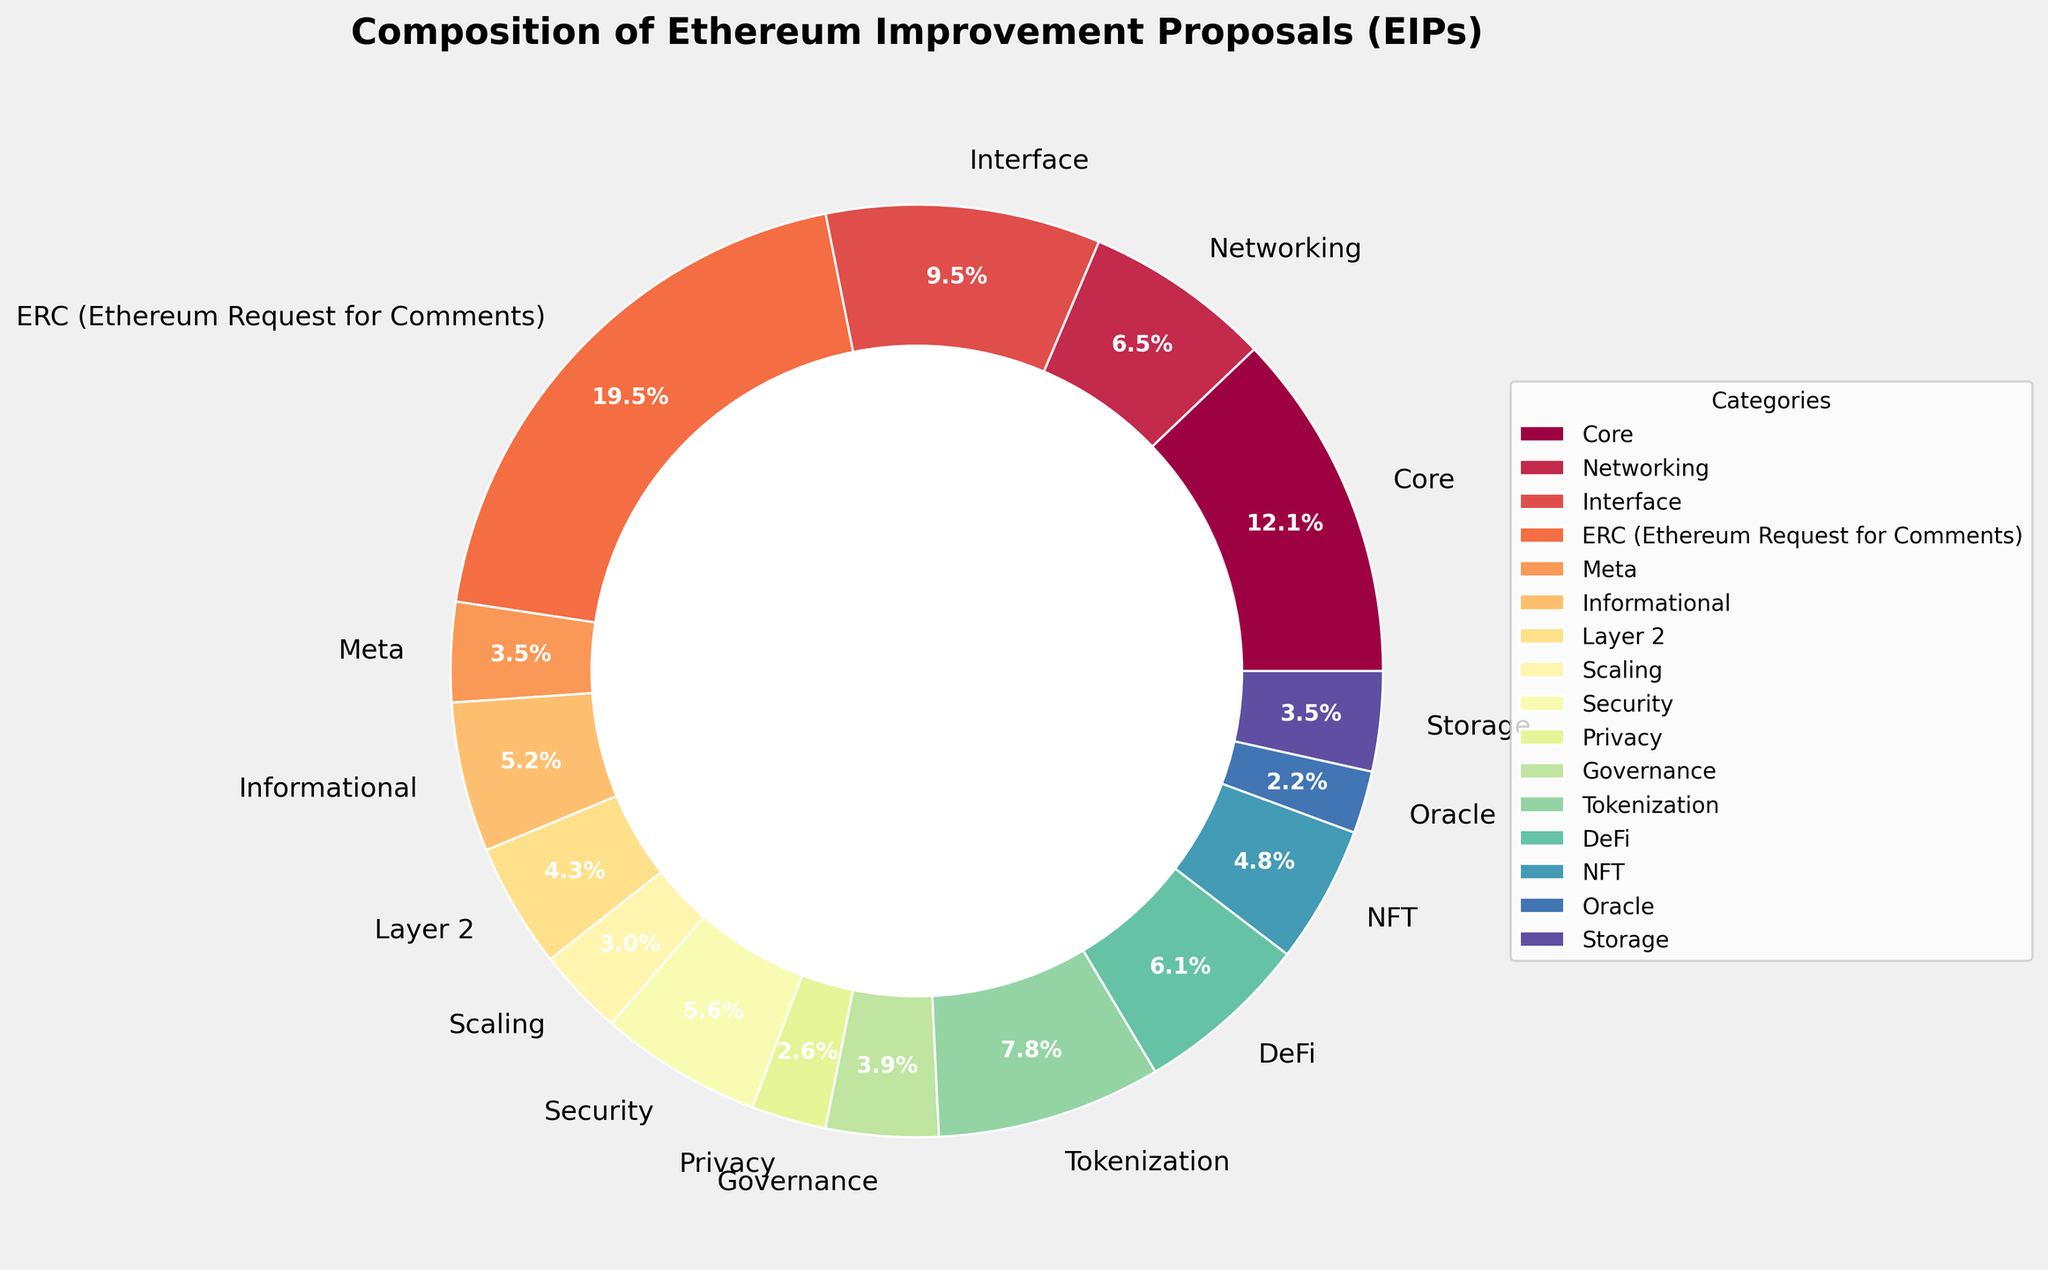Which category has the largest number of EIPs? The largest segment in the pie chart, which is labeled with the highest percentage, corresponds to the ERC (Ethereum Request for Comments) category, with a count of 45.
Answer: ERC (Ethereum Request for Comments) What is the total percentage of Core and Networking EIPs combined? The Core has 28 EIPs, and Networking has 15 EIPs. Summing their percentages (14.1% for Core and 7.5% for Networking) gives the combined percentage of 21.6%.
Answer: 21.6% Is the count of Interface EIPs greater than the count of Informational EIPs? The segment for Interface shows 22 EIPs, whereas the segment for Informational shows 12 EIPs. Comparing them, 22 > 12, so the count for Interface is greater.
Answer: Yes Which category has the smallest number of EIPs and what is its count? The smallest segment in the pie chart, which is the smallest in both size and percentage, corresponds to the Oracle category with 5 EIPs.
Answer: Oracle, 5 How many categories have more than 10 but fewer than 20 EIPs? The categories with counts between 10 and 20 are Interface (22), Tokenization (18), DeFi (14), NFT (11), and Security (13), totaling five categories.
Answer: 5 What's the difference between the counts of Security EIPs and Privacy EIPs? Security has 13 EIPs and Privacy has 6 EIPs. The difference is calculated as 13 - 6 = 7.
Answer: 7 What is the combined count of DeFi, NFT, and Tokenization EIPs? Summing the counts for DeFi (14), NFT (11), and Tokenization (18) gives a total of 14 + 11 + 18 = 43.
Answer: 43 How does the percentage of Scaling EIPs compare to the percentage of Storage EIPs? Scaling has 7 EIPs and Storage has 8 EIPs. Their respective percentages would be 7 * 100 / 183 ≈ 3.8% and 8 * 100 / 183 ≈ 4.4%. Hence, Scaling has a smaller percentage than Storage.
Answer: Scaling has a smaller percentage Are Meta and Governance EIPs together more than the combined count of Oracles and Privacy EIPs? Meta has 8 EIPs and Governance has 9 EIPs, totaling 17. Oracle has 5 EIPs and Privacy has 6 EIPs, totaling 11. Comparing these sums, 17 > 11, so Meta and Governance combined are greater.
Answer: Yes 